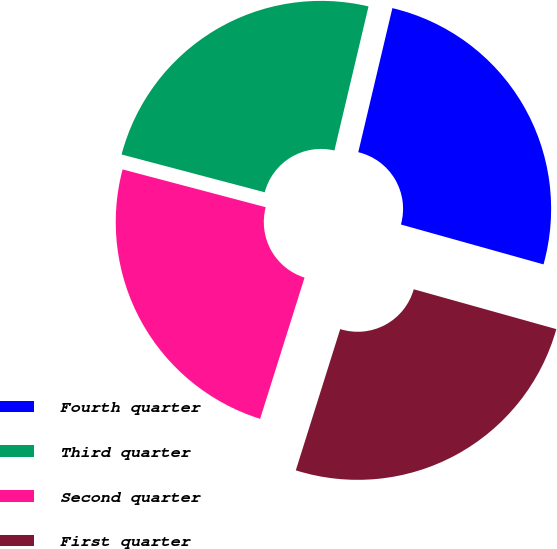<chart> <loc_0><loc_0><loc_500><loc_500><pie_chart><fcel>Fourth quarter<fcel>Third quarter<fcel>Second quarter<fcel>First quarter<nl><fcel>25.64%<fcel>24.59%<fcel>24.26%<fcel>25.51%<nl></chart> 